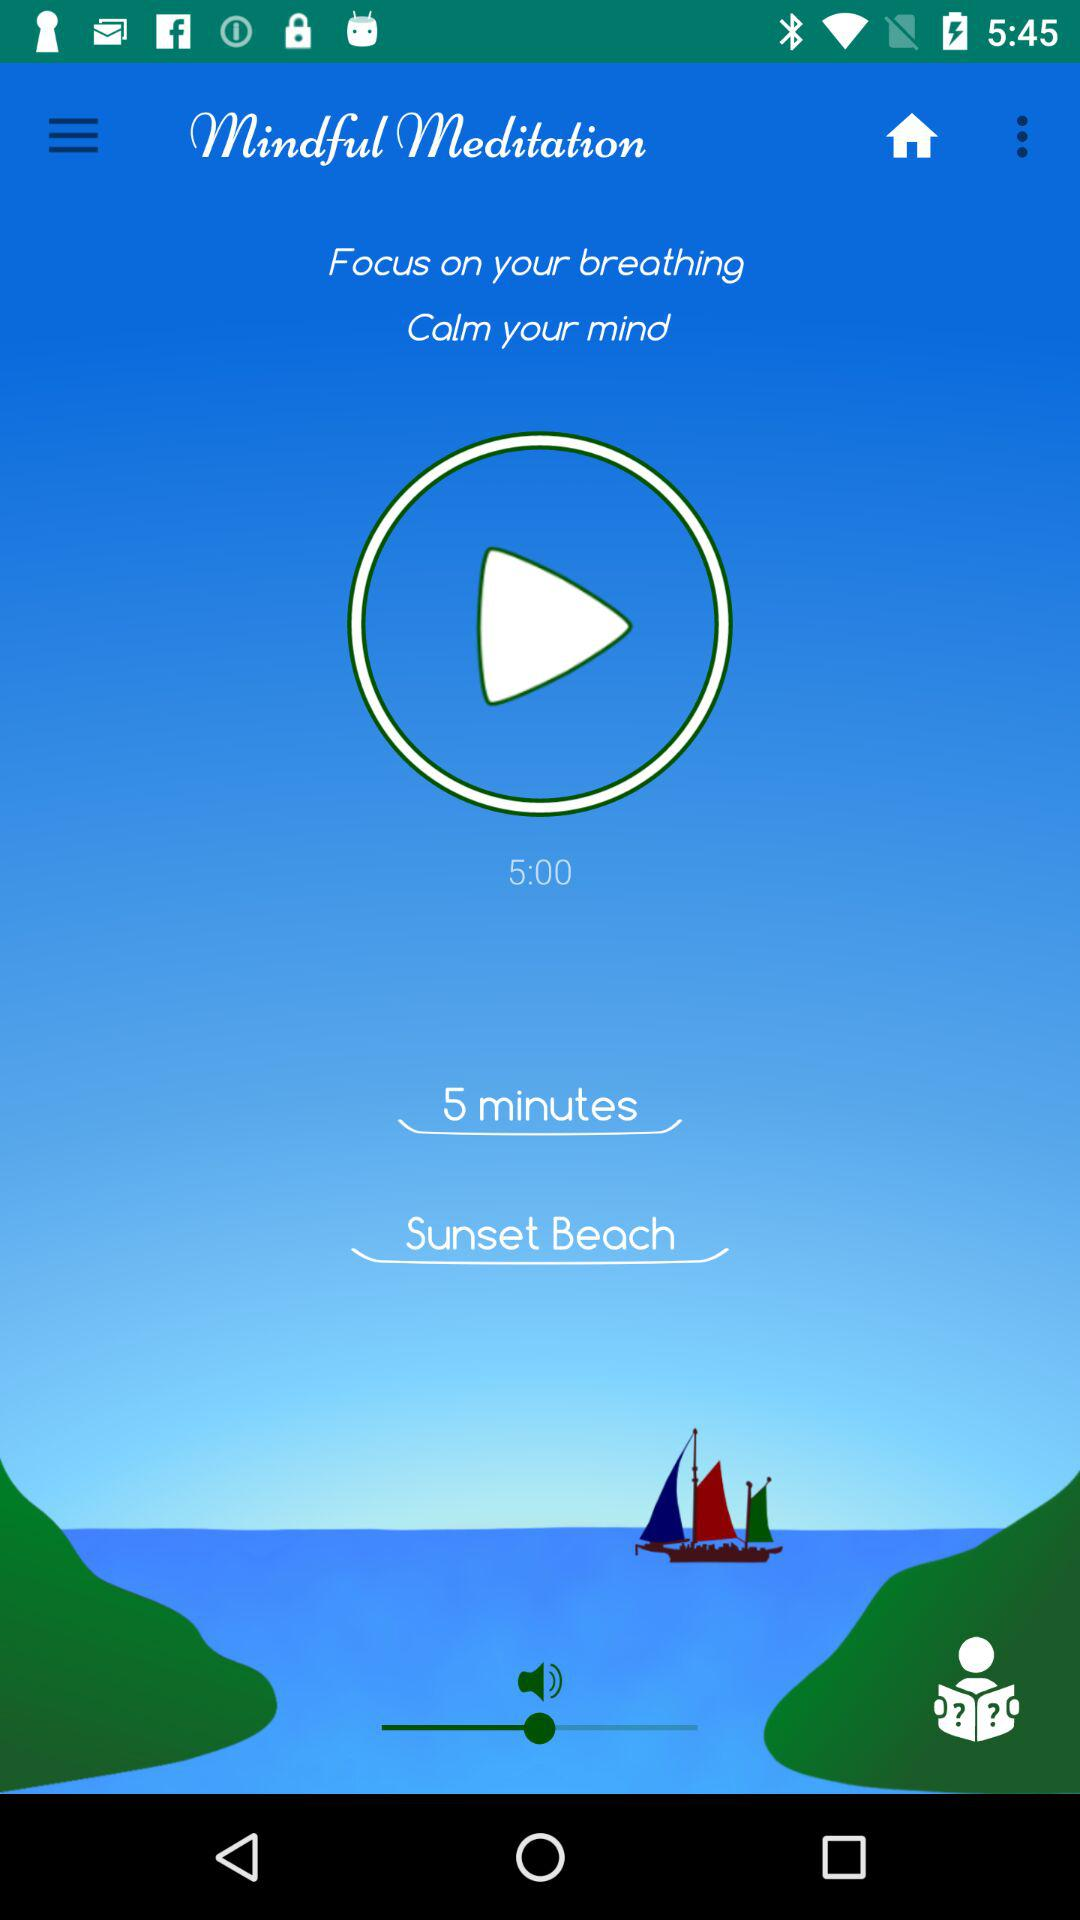What is the duration of mindful meditation? The duration is 5 minutes. 